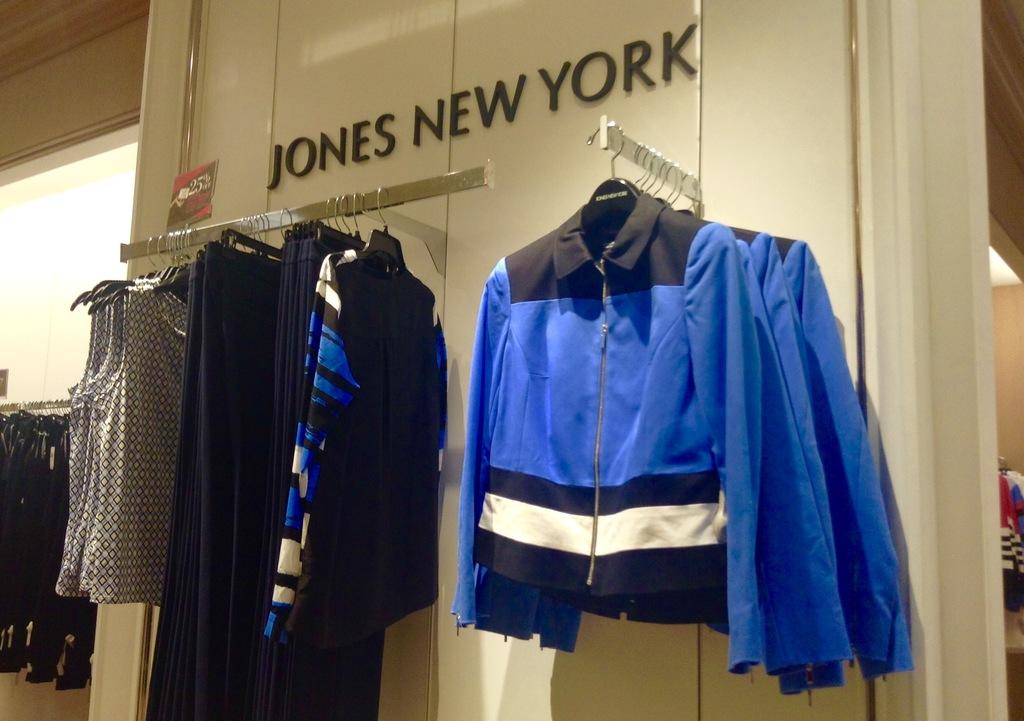Where is this store located?
Offer a terse response. New york. Whats the name of thestore?
Offer a very short reply. Jones new york. 